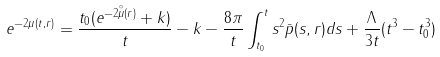<formula> <loc_0><loc_0><loc_500><loc_500>e ^ { - 2 \mu ( t , r ) } = \frac { t _ { 0 } ( e ^ { - 2 \overset { \circ } { \mu } ( r ) } + k ) } { t } - k - \frac { 8 \pi } { t } \int _ { t _ { 0 } } ^ { t } s ^ { 2 } \bar { p } ( s , r ) d s + \frac { \Lambda } { 3 t } ( t ^ { 3 } - t _ { 0 } ^ { 3 } )</formula> 